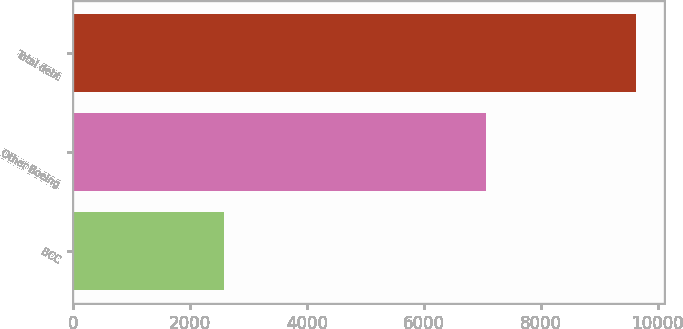Convert chart. <chart><loc_0><loc_0><loc_500><loc_500><bar_chart><fcel>BCC<fcel>Other Boeing<fcel>Total debt<nl><fcel>2577<fcel>7058<fcel>9635<nl></chart> 